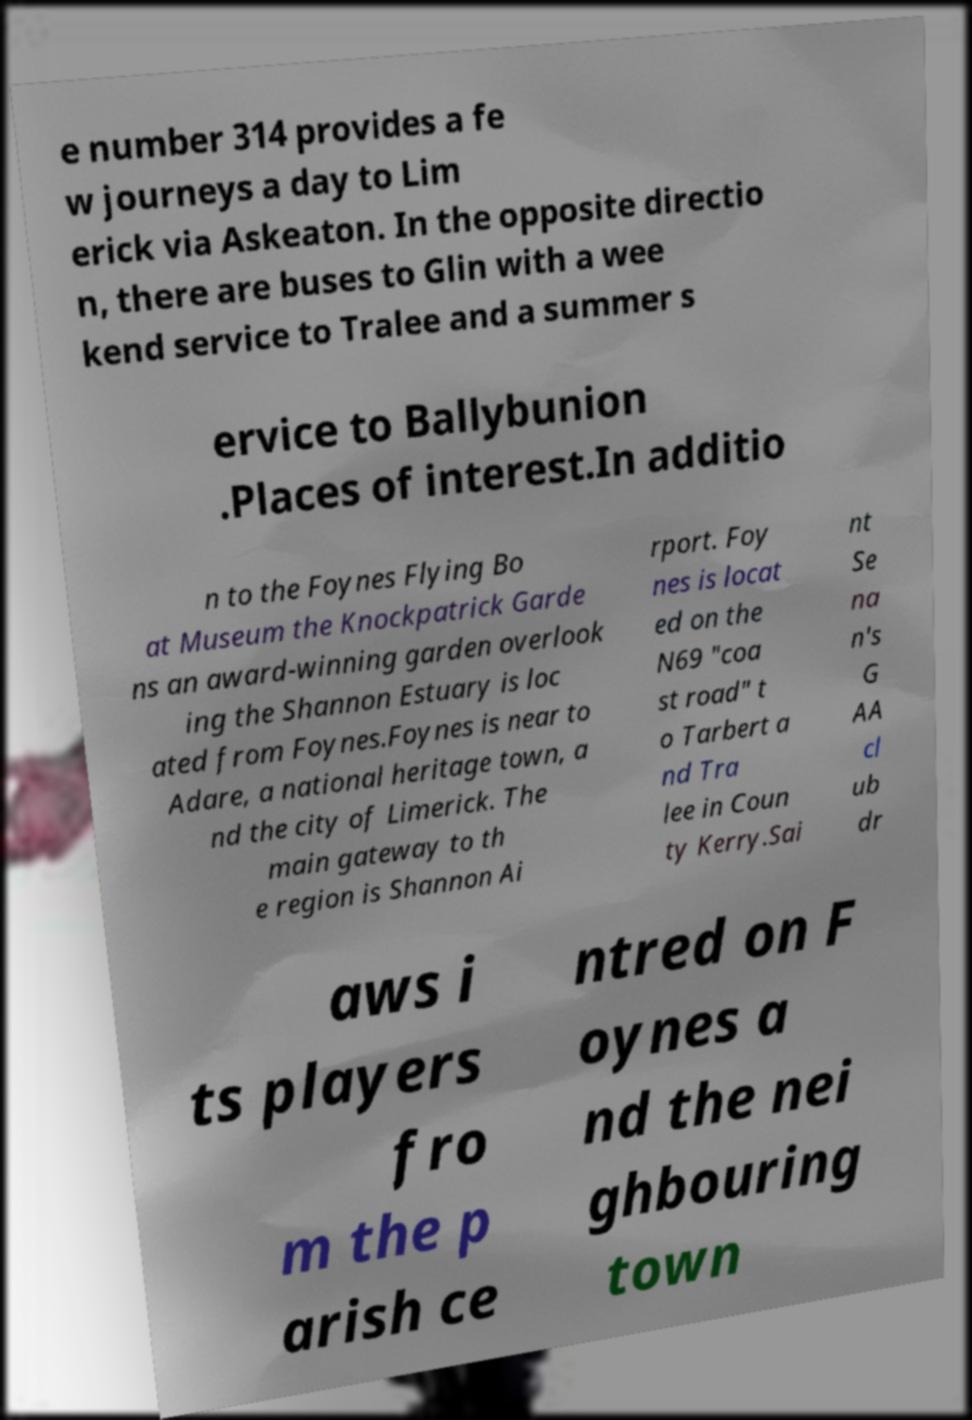Please read and relay the text visible in this image. What does it say? e number 314 provides a fe w journeys a day to Lim erick via Askeaton. In the opposite directio n, there are buses to Glin with a wee kend service to Tralee and a summer s ervice to Ballybunion .Places of interest.In additio n to the Foynes Flying Bo at Museum the Knockpatrick Garde ns an award-winning garden overlook ing the Shannon Estuary is loc ated from Foynes.Foynes is near to Adare, a national heritage town, a nd the city of Limerick. The main gateway to th e region is Shannon Ai rport. Foy nes is locat ed on the N69 "coa st road" t o Tarbert a nd Tra lee in Coun ty Kerry.Sai nt Se na n's G AA cl ub dr aws i ts players fro m the p arish ce ntred on F oynes a nd the nei ghbouring town 